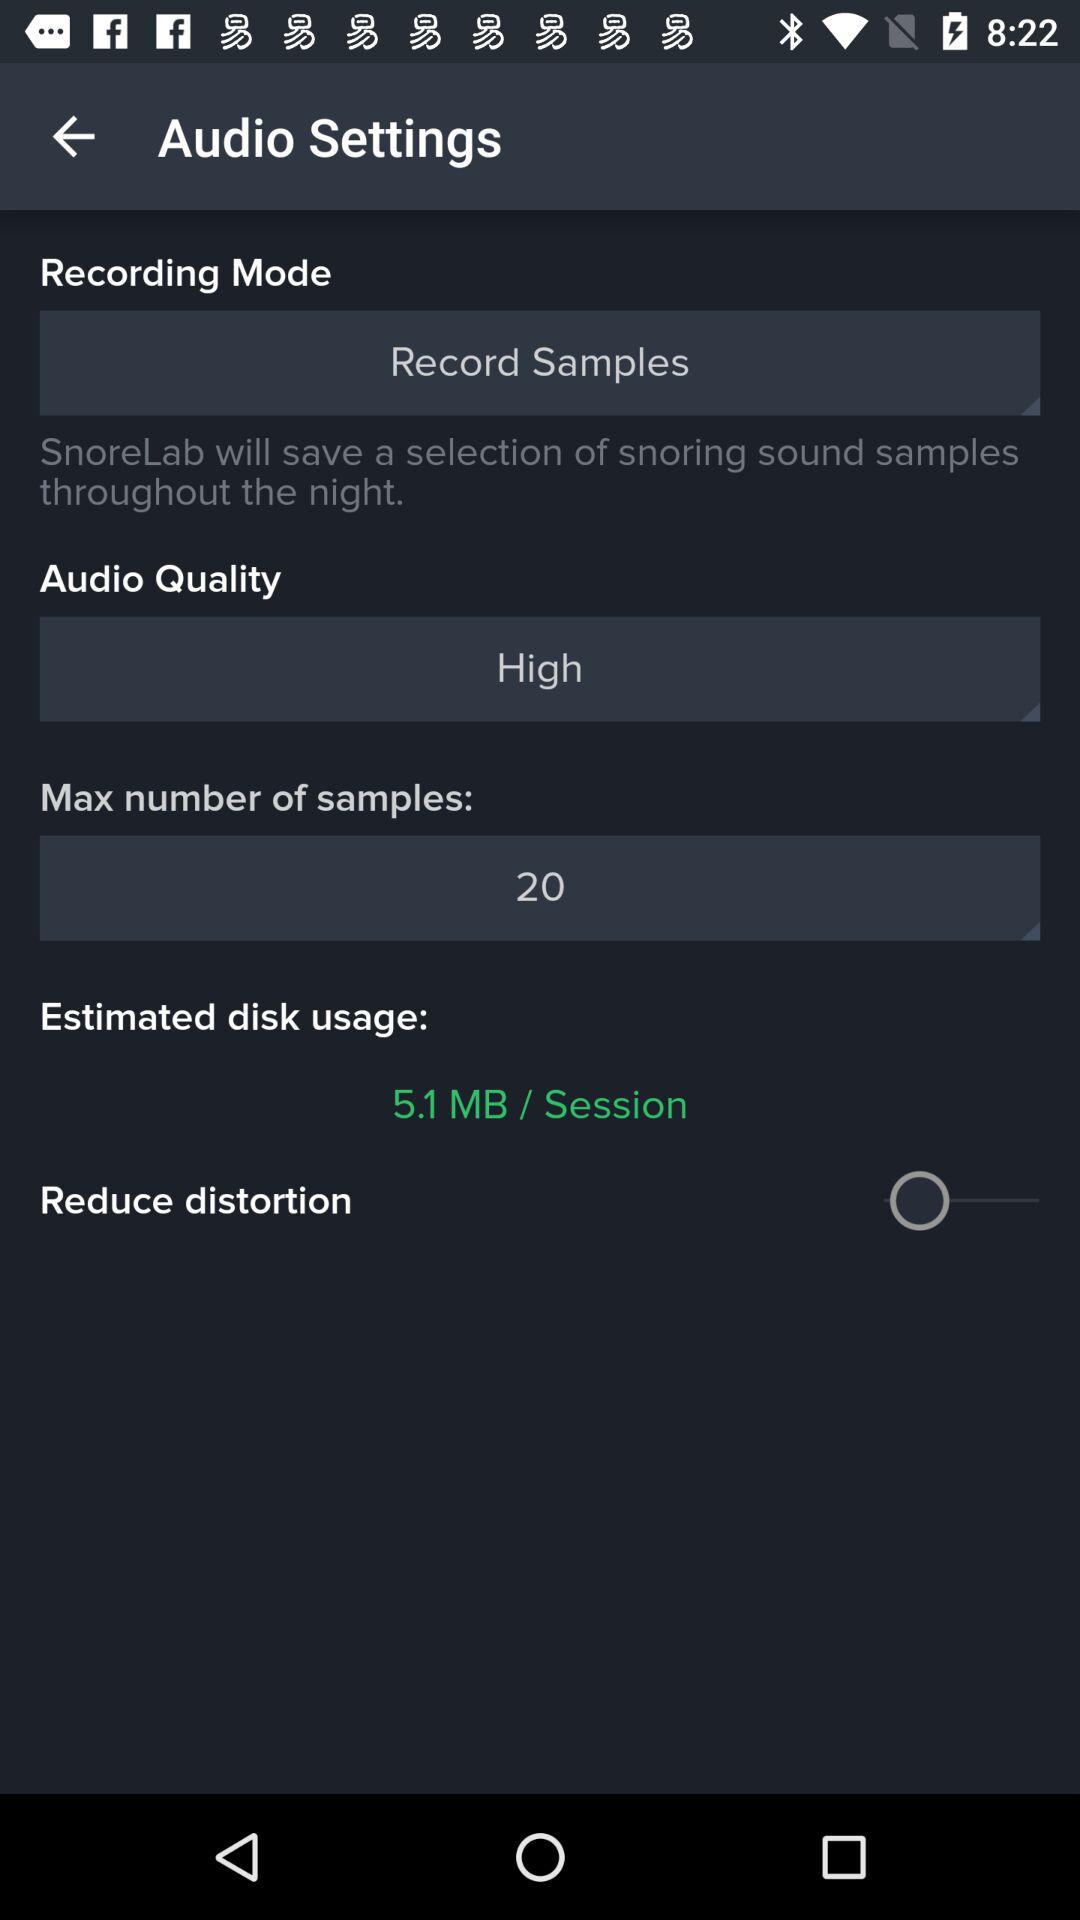What is the status of the "Reduce distortion"? The status of the "Reduce distortion" is off. 